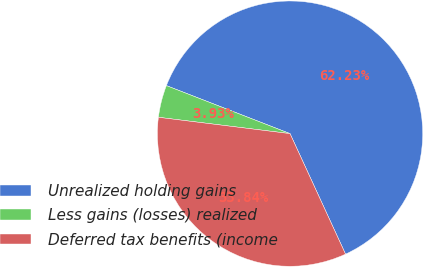Convert chart. <chart><loc_0><loc_0><loc_500><loc_500><pie_chart><fcel>Unrealized holding gains<fcel>Less gains (losses) realized<fcel>Deferred tax benefits (income<nl><fcel>62.24%<fcel>3.93%<fcel>33.84%<nl></chart> 